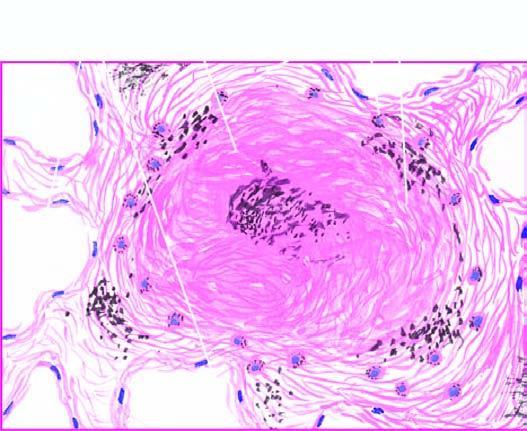does the silicotic nodule consist of hyaline centre surrounded by concentric layers of collagen which are further enclosed by fibroblasts and dust-laden macrophages?
Answer the question using a single word or phrase. Yes 